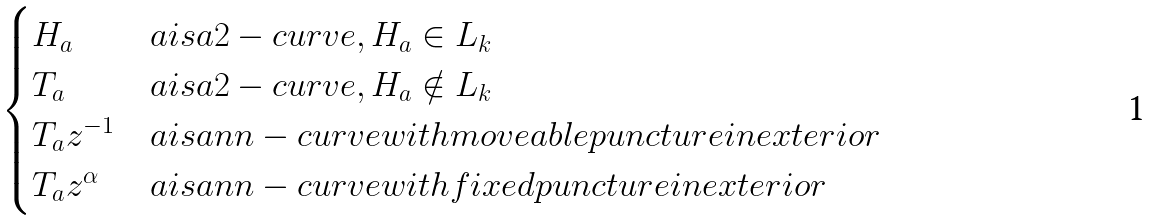Convert formula to latex. <formula><loc_0><loc_0><loc_500><loc_500>\begin{cases} H _ { a } & a i s a 2 - c u r v e , H _ { a } \in L _ { k } \\ T _ { a } & a i s a 2 - c u r v e , H _ { a } \notin L _ { k } \\ T _ { a } z ^ { - 1 } & a i s a n n - c u r v e w i t h m o v e a b l e p u n c t u r e i n e x t e r i o r \\ T _ { a } z ^ { \alpha } & a i s a n n - c u r v e w i t h f i x e d p u n c t u r e i n e x t e r i o r \\ \end{cases}</formula> 